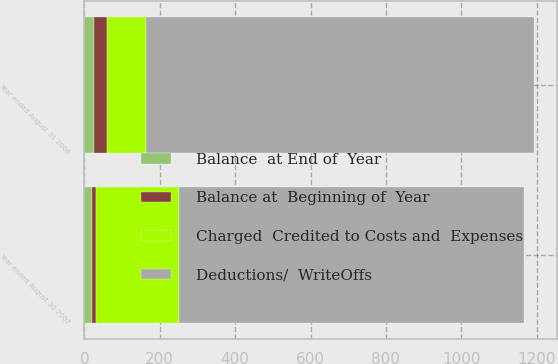<chart> <loc_0><loc_0><loc_500><loc_500><stacked_bar_chart><ecel><fcel>Year ended August 30 2007<fcel>Year ended August 31 2006<nl><fcel>Deductions/  WriteOffs<fcel>915<fcel>1029<nl><fcel>Balance at  Beginning of  Year<fcel>12<fcel>36<nl><fcel>Charged  Credited to Costs and  Expenses<fcel>219<fcel>103<nl><fcel>Balance  at End of  Year<fcel>20<fcel>25<nl></chart> 